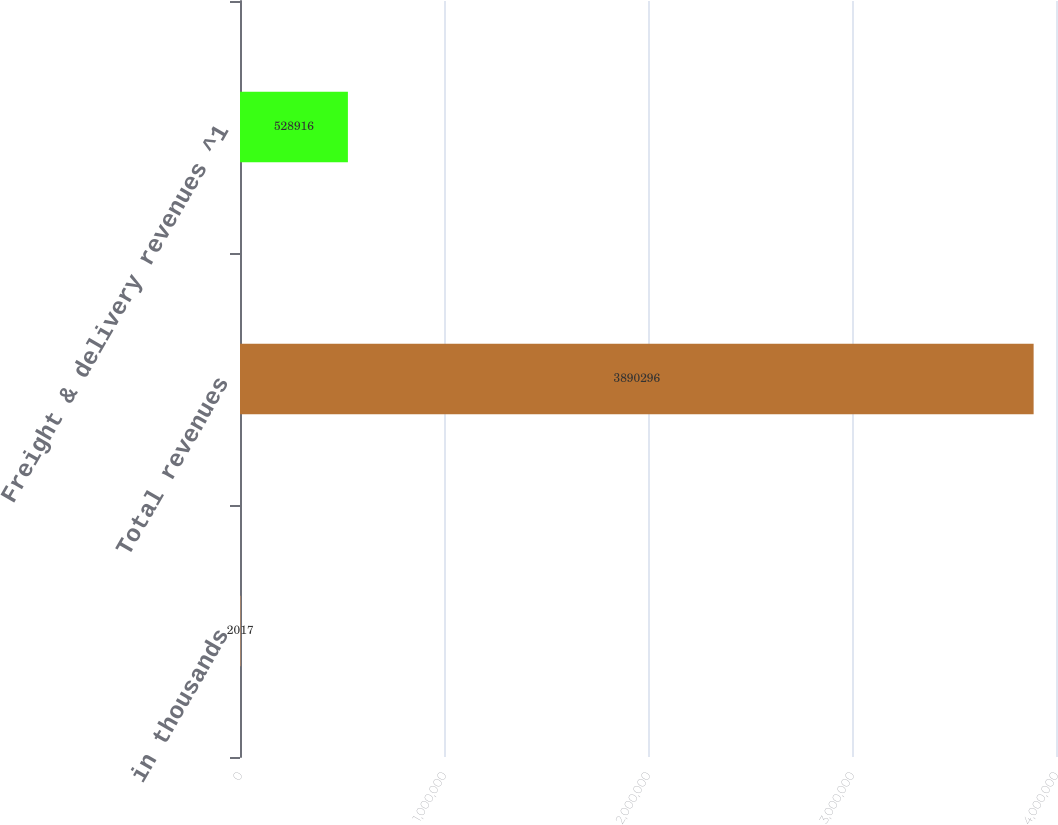<chart> <loc_0><loc_0><loc_500><loc_500><bar_chart><fcel>in thousands<fcel>Total revenues<fcel>Freight & delivery revenues ^1<nl><fcel>2017<fcel>3.8903e+06<fcel>528916<nl></chart> 